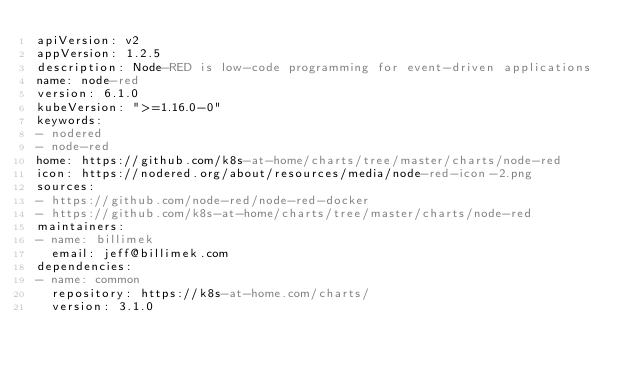Convert code to text. <code><loc_0><loc_0><loc_500><loc_500><_YAML_>apiVersion: v2
appVersion: 1.2.5
description: Node-RED is low-code programming for event-driven applications
name: node-red
version: 6.1.0
kubeVersion: ">=1.16.0-0"
keywords:
- nodered
- node-red
home: https://github.com/k8s-at-home/charts/tree/master/charts/node-red
icon: https://nodered.org/about/resources/media/node-red-icon-2.png
sources:
- https://github.com/node-red/node-red-docker
- https://github.com/k8s-at-home/charts/tree/master/charts/node-red
maintainers:
- name: billimek
  email: jeff@billimek.com
dependencies:
- name: common
  repository: https://k8s-at-home.com/charts/
  version: 3.1.0
</code> 